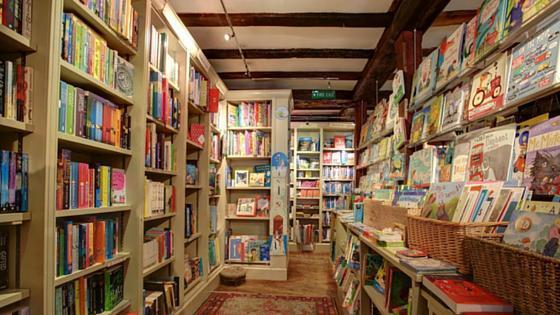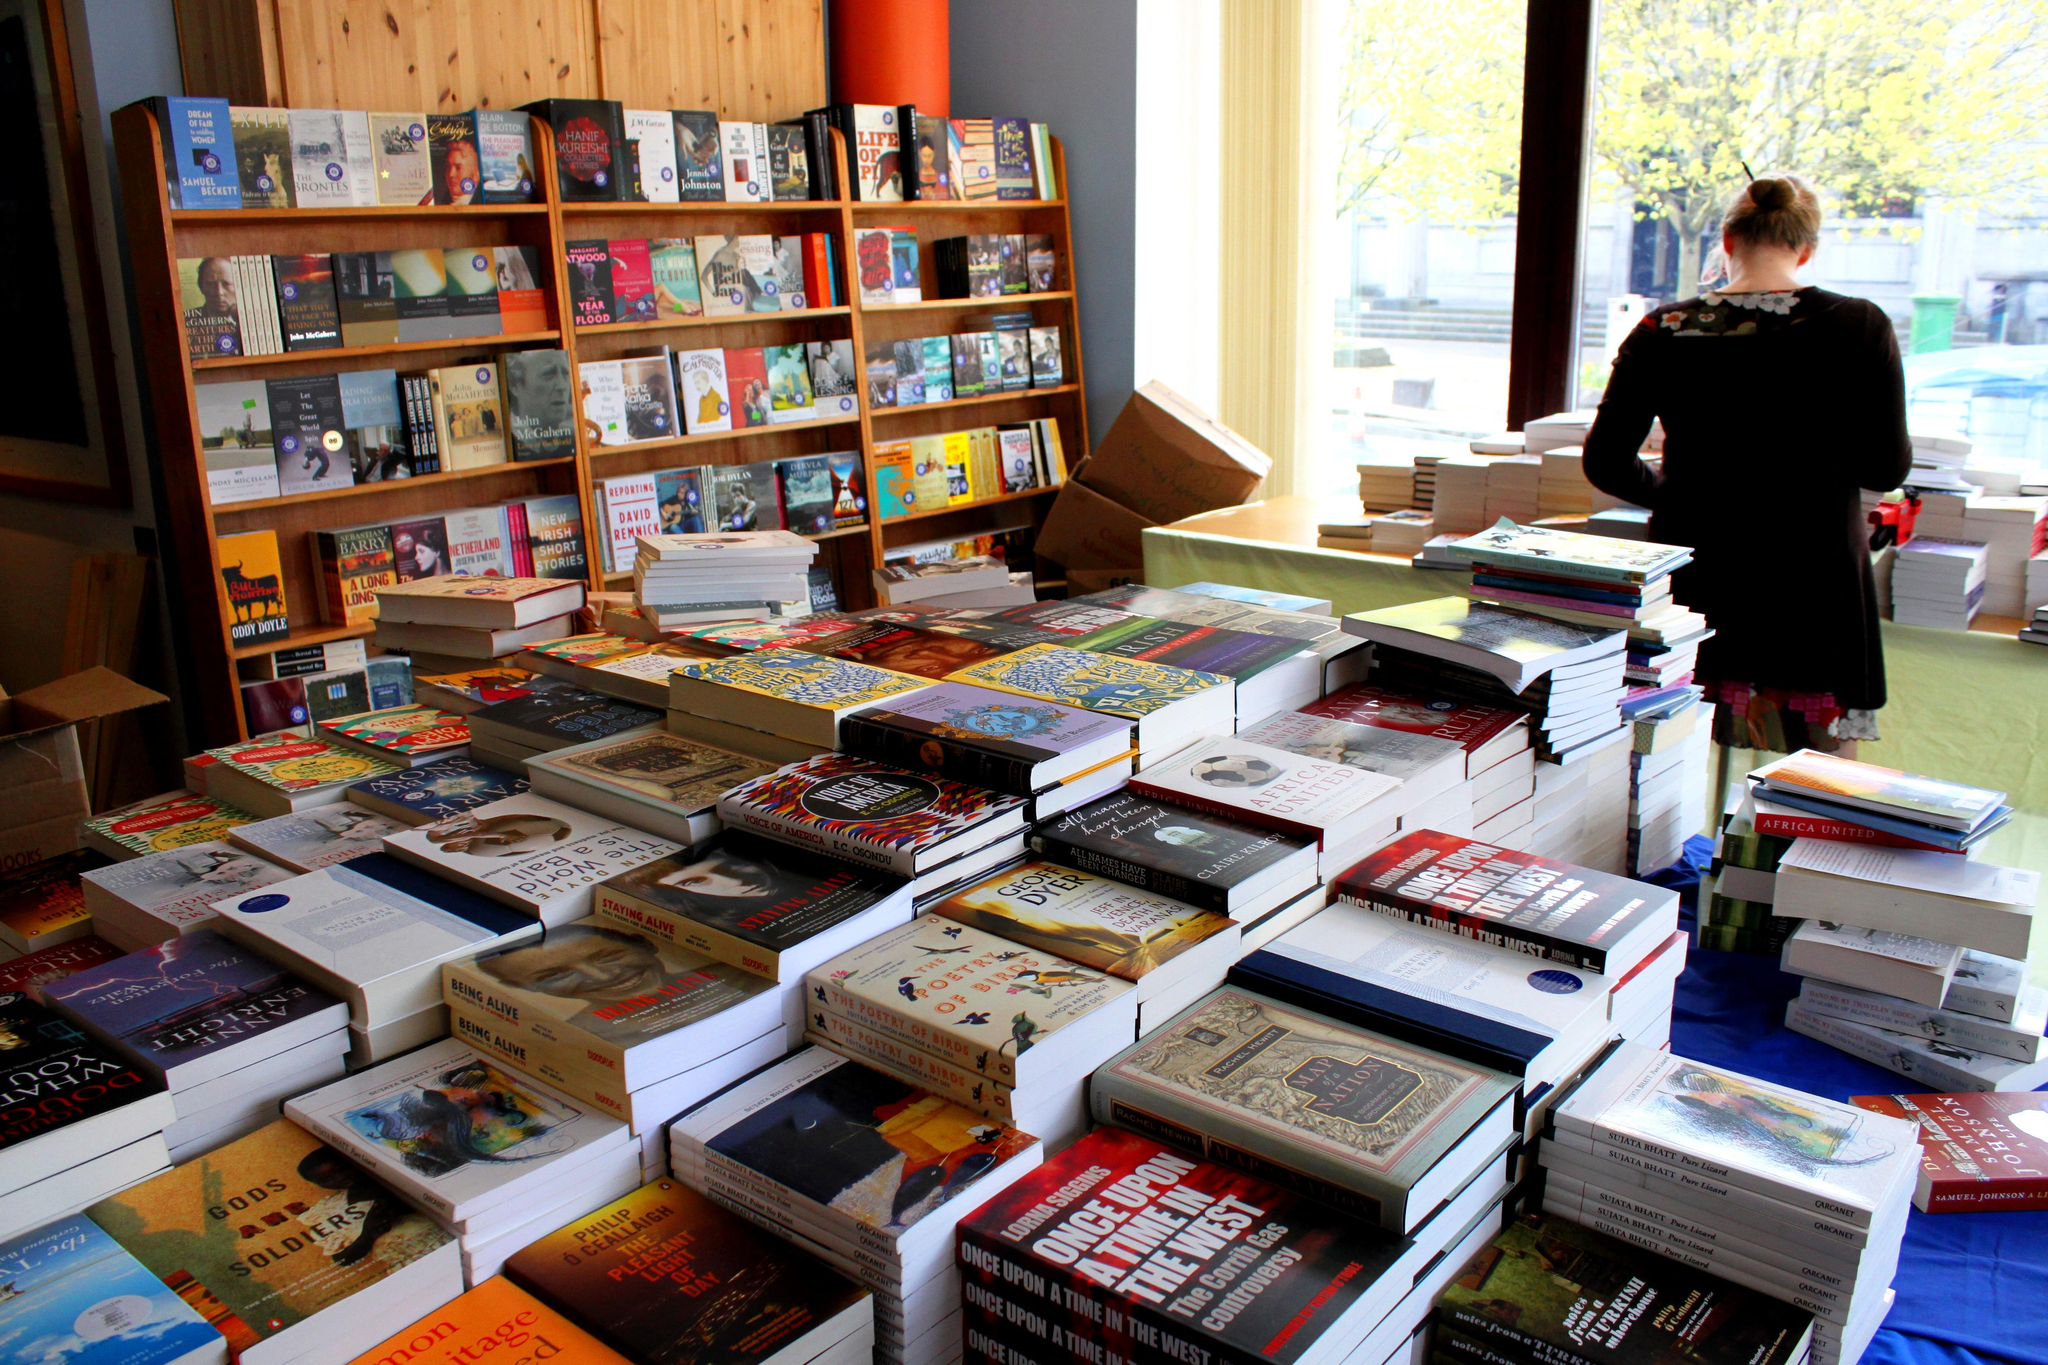The first image is the image on the left, the second image is the image on the right. Considering the images on both sides, is "There are three or more people shopping for books in the left image." valid? Answer yes or no. No. The first image is the image on the left, the second image is the image on the right. Assess this claim about the two images: "A wall in one image has windows that show a glimpse of outside the bookshop.". Correct or not? Answer yes or no. Yes. 